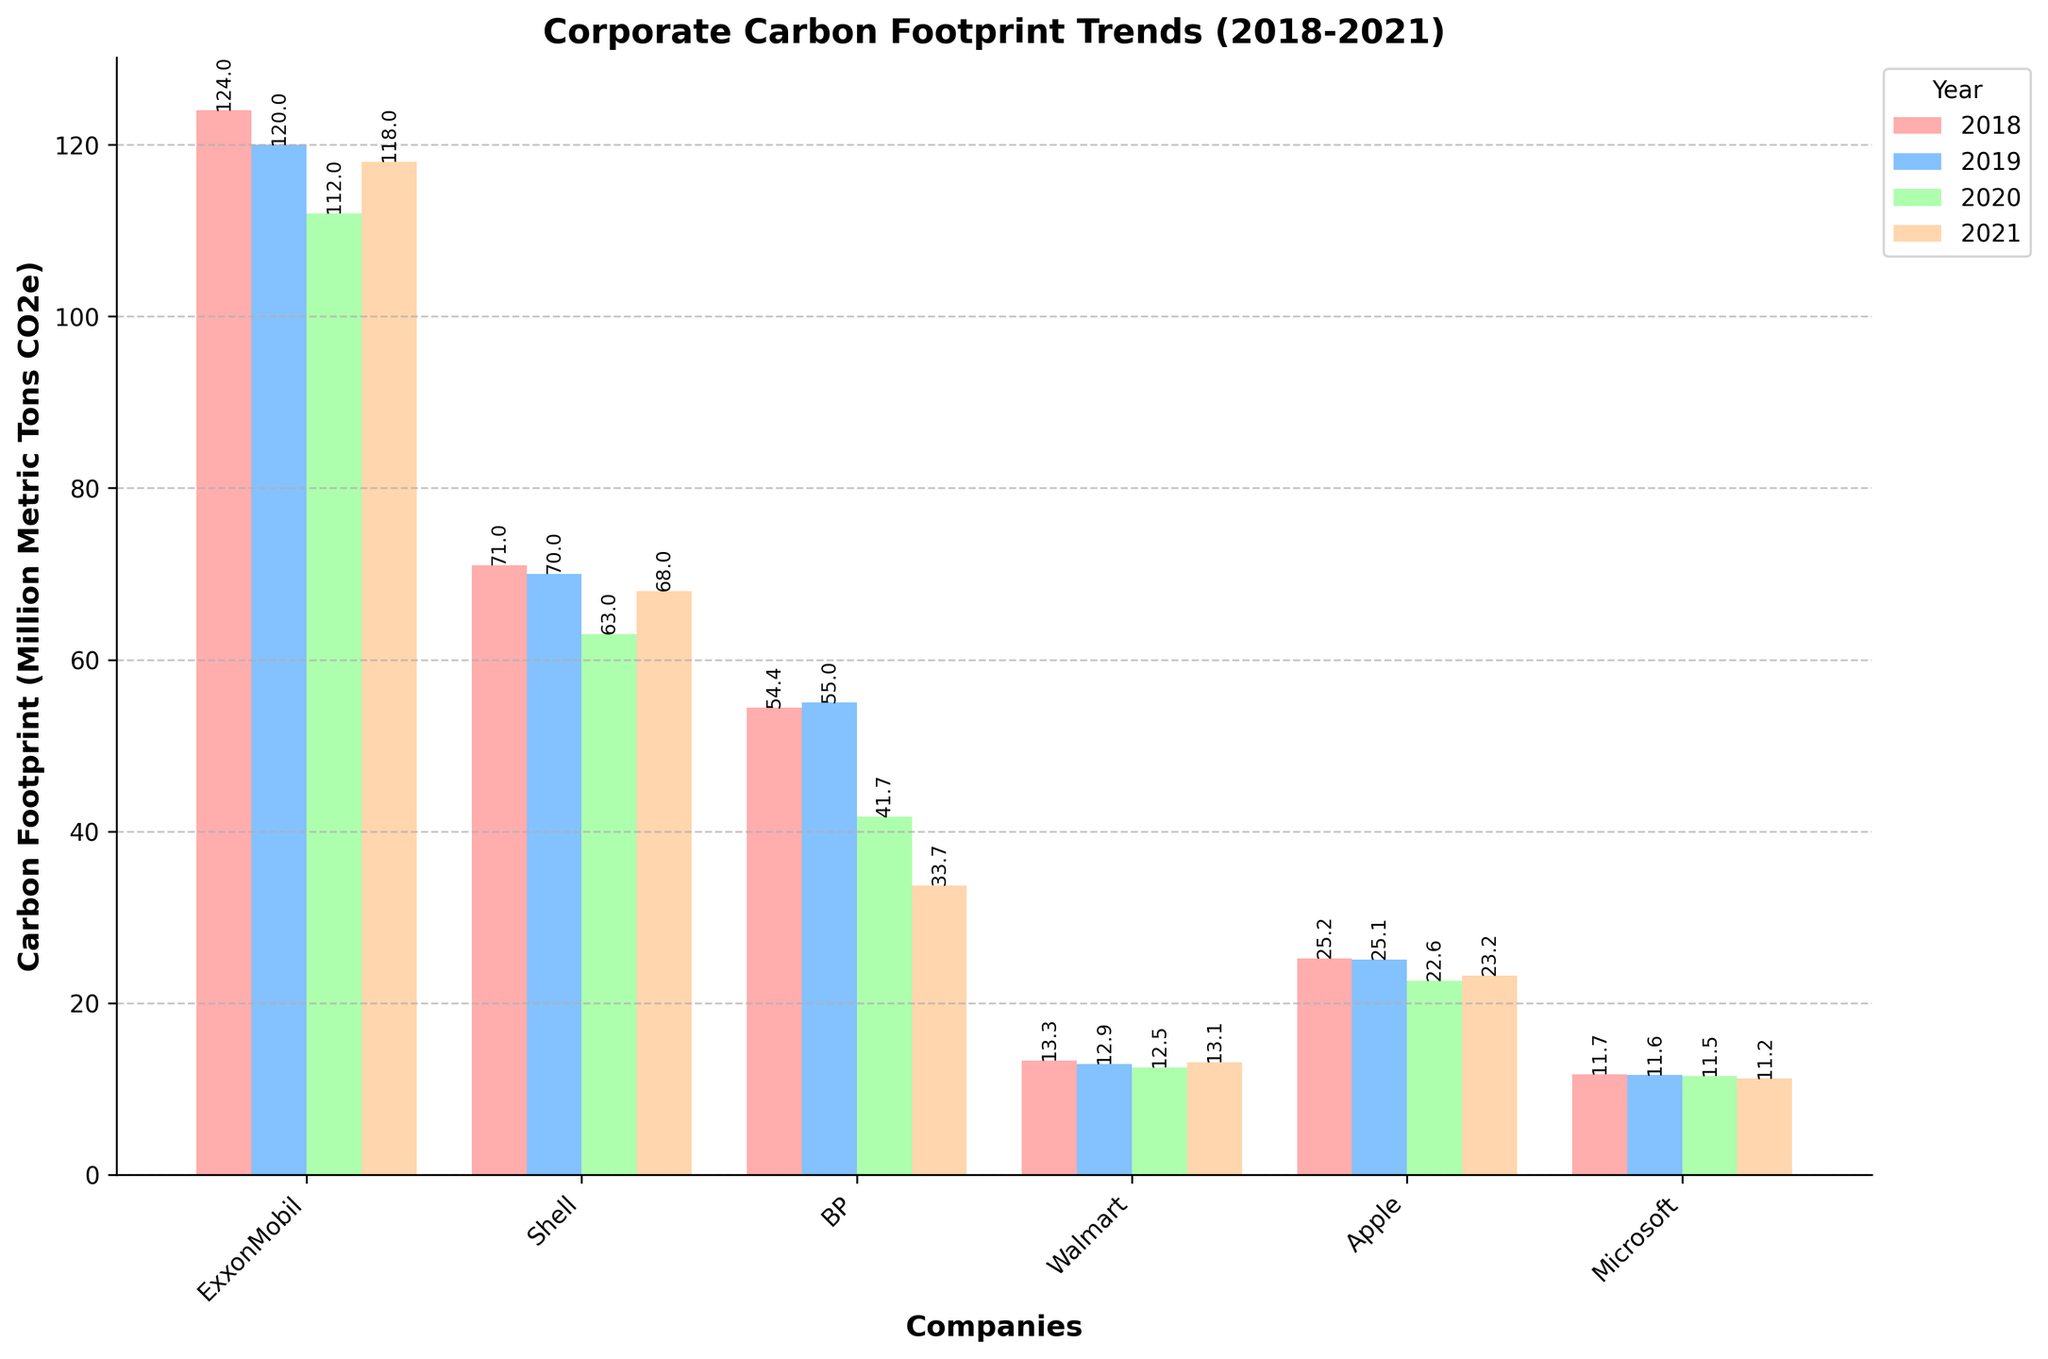Which company had the highest carbon footprint in 2018? Looking at the bars for each company in 2018, the tallest bar represents ExxonMobil.
Answer: ExxonMobil Which company showed the most significant decrease in carbon footprint between 2018 and 2021? By comparing the heights of the bars for each company from 2018 to 2021, BP showed the most noticeable decrease from 54.4 to 33.7.
Answer: BP How much did Shell’s carbon footprint change from 2018 to 2021? Shell's footprint decreased from 71 in 2018 to 68 in 2021. The change is 71 - 68.
Answer: 3 million metric tons CO2e Which company had a higher carbon footprint in 2020, Walmart or Microsoft? Comparing the heights of the bars for Walmart and Microsoft in 2020, Walmart's bar is taller.
Answer: Walmart What was the combined carbon footprint of BP and Apple in 2019? Adding the heights of the bars for BP (55.0) and Apple (25.1) in 2019: 55.0 + 25.1 = 80.1.
Answer: 80.1 million metric tons CO2e Which company had the smallest variation in carbon footprint between 2018 and 2021? The company with the smallest variation is identified by comparing the differences between the highest and lowest bars across the years. Microsoft ranges from 11.7 to 11.2, which is the smallest range of 0.5.
Answer: Microsoft How did ExxonMobil’s carbon footprint change from 2019 to 2020? ExxonMobil's footprint decreased from 120 in 2019 to 112 in 2020. Calculating the difference: 120 - 112.
Answer: 8 million metric tons CO2e In which year did Walmart have its lowest carbon footprint? By examining the heights of Walmart's bars for each year, the shortest bar is for 2020.
Answer: 2020 How does the average carbon footprint of ExxonMobil from 2018 to 2021 compare to that of Shell for the same period? Calculate the average for ExxonMobil: (124 + 120 + 112 + 118) / 4 = 118.5. For Shell: (71 + 70 + 63 + 68) / 4 = 68. The average for ExxonMobil is higher.
Answer: ExxonMobil's average is higher Which company showed an increase in carbon footprint from 2020 to 2021? By looking at the height difference from 2020 to 2021, ExxonMobil and Walmart showed an increase.
Answer: ExxonMobil, Walmart 